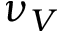<formula> <loc_0><loc_0><loc_500><loc_500>\nu _ { V }</formula> 